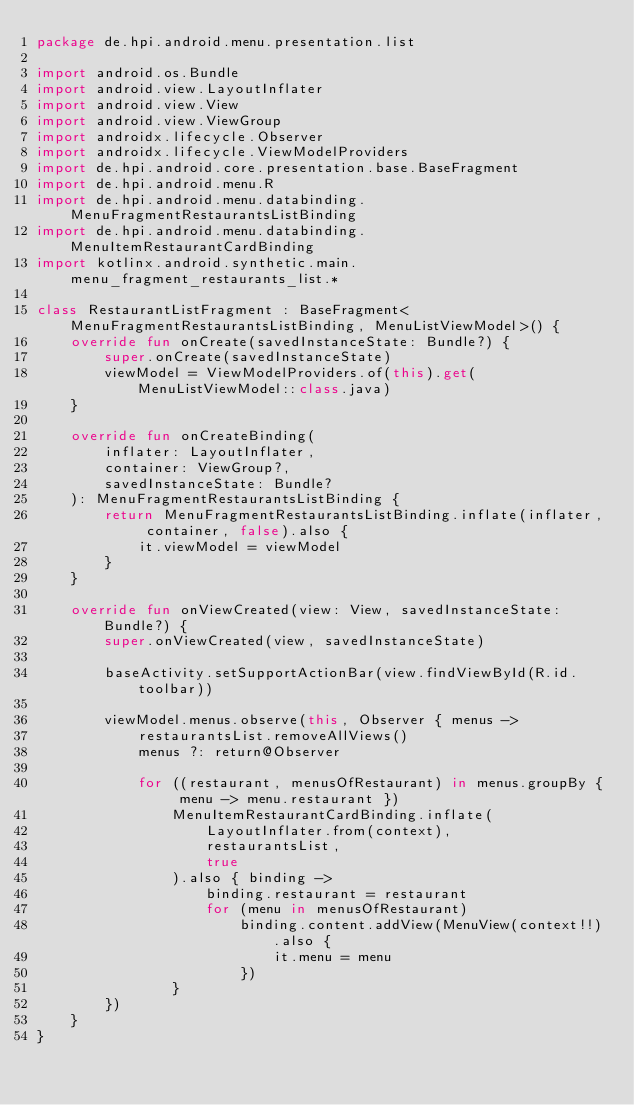Convert code to text. <code><loc_0><loc_0><loc_500><loc_500><_Kotlin_>package de.hpi.android.menu.presentation.list

import android.os.Bundle
import android.view.LayoutInflater
import android.view.View
import android.view.ViewGroup
import androidx.lifecycle.Observer
import androidx.lifecycle.ViewModelProviders
import de.hpi.android.core.presentation.base.BaseFragment
import de.hpi.android.menu.R
import de.hpi.android.menu.databinding.MenuFragmentRestaurantsListBinding
import de.hpi.android.menu.databinding.MenuItemRestaurantCardBinding
import kotlinx.android.synthetic.main.menu_fragment_restaurants_list.*

class RestaurantListFragment : BaseFragment<MenuFragmentRestaurantsListBinding, MenuListViewModel>() {
    override fun onCreate(savedInstanceState: Bundle?) {
        super.onCreate(savedInstanceState)
        viewModel = ViewModelProviders.of(this).get(MenuListViewModel::class.java)
    }

    override fun onCreateBinding(
        inflater: LayoutInflater,
        container: ViewGroup?,
        savedInstanceState: Bundle?
    ): MenuFragmentRestaurantsListBinding {
        return MenuFragmentRestaurantsListBinding.inflate(inflater, container, false).also {
            it.viewModel = viewModel
        }
    }

    override fun onViewCreated(view: View, savedInstanceState: Bundle?) {
        super.onViewCreated(view, savedInstanceState)

        baseActivity.setSupportActionBar(view.findViewById(R.id.toolbar))

        viewModel.menus.observe(this, Observer { menus ->
            restaurantsList.removeAllViews()
            menus ?: return@Observer

            for ((restaurant, menusOfRestaurant) in menus.groupBy { menu -> menu.restaurant })
                MenuItemRestaurantCardBinding.inflate(
                    LayoutInflater.from(context),
                    restaurantsList,
                    true
                ).also { binding ->
                    binding.restaurant = restaurant
                    for (menu in menusOfRestaurant)
                        binding.content.addView(MenuView(context!!).also {
                            it.menu = menu
                        })
                }
        })
    }
}
</code> 